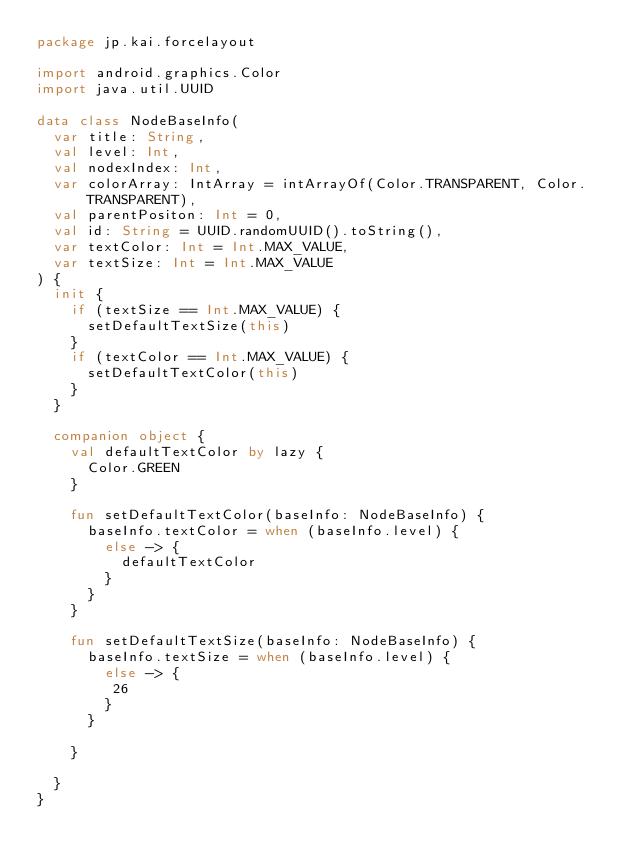<code> <loc_0><loc_0><loc_500><loc_500><_Kotlin_>package jp.kai.forcelayout

import android.graphics.Color
import java.util.UUID

data class NodeBaseInfo(
  var title: String,
  val level: Int,
  val nodexIndex: Int,
  var colorArray: IntArray = intArrayOf(Color.TRANSPARENT, Color.TRANSPARENT),
  val parentPositon: Int = 0,
  val id: String = UUID.randomUUID().toString(),
  var textColor: Int = Int.MAX_VALUE,
  var textSize: Int = Int.MAX_VALUE
) {
  init {
    if (textSize == Int.MAX_VALUE) {
      setDefaultTextSize(this)
    }
    if (textColor == Int.MAX_VALUE) {
      setDefaultTextColor(this)
    }
  }

  companion object {
    val defaultTextColor by lazy {
      Color.GREEN
    }

    fun setDefaultTextColor(baseInfo: NodeBaseInfo) {
      baseInfo.textColor = when (baseInfo.level) {
        else -> {
          defaultTextColor
        }
      }
    }

    fun setDefaultTextSize(baseInfo: NodeBaseInfo) {
      baseInfo.textSize = when (baseInfo.level) {
        else -> {
         26
        }
      }

    }

  }
}</code> 